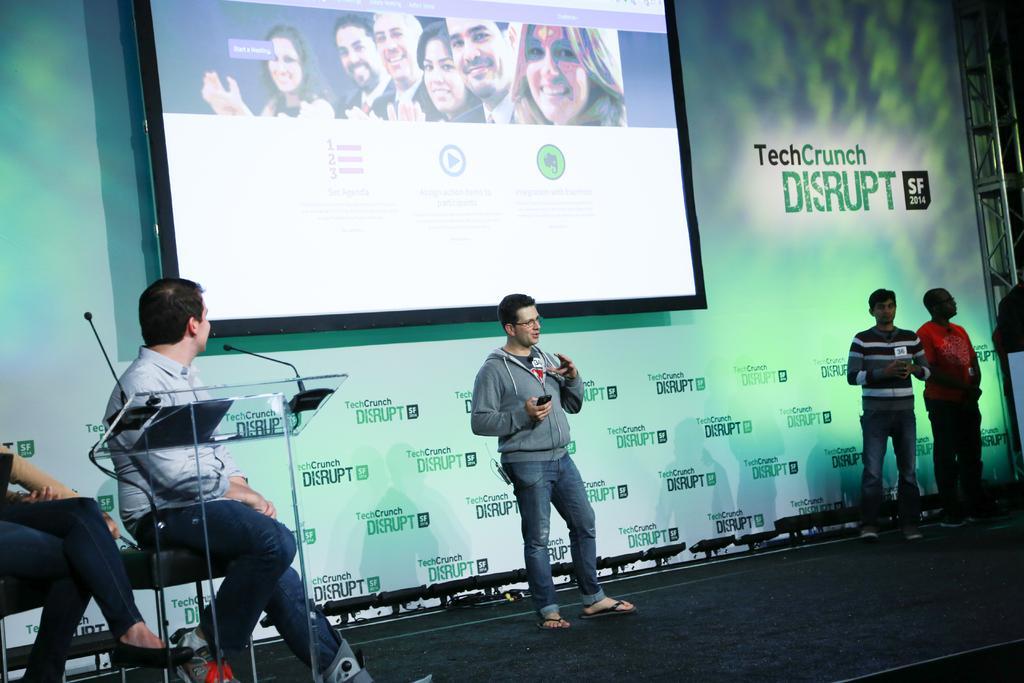How would you summarize this image in a sentence or two? In this image I can see in the middle a man is standing and speaking, he wore sweater, trouser. At the top there is the electronic display, on the left side few persons are sitting on the chairs. On the right side few persons are standing on the stage. 